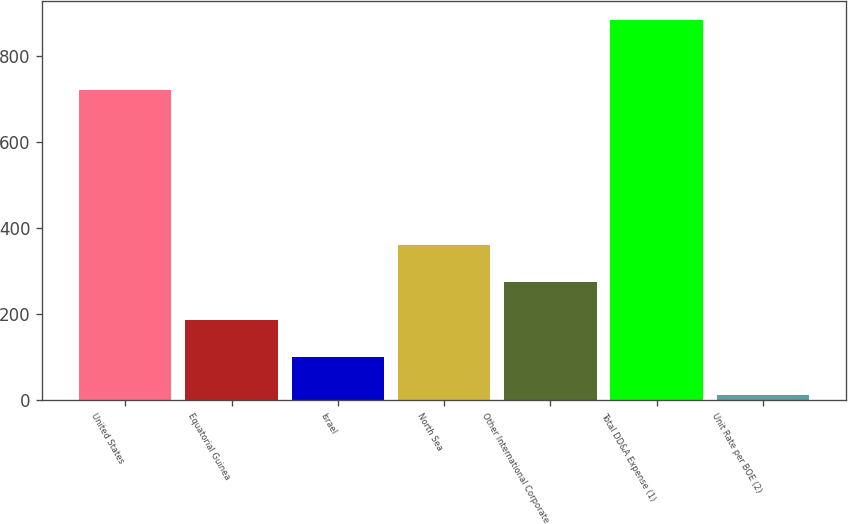Convert chart to OTSL. <chart><loc_0><loc_0><loc_500><loc_500><bar_chart><fcel>United States<fcel>Equatorial Guinea<fcel>Israel<fcel>North Sea<fcel>Other International Corporate<fcel>Total DD&A Expense (1)<fcel>Unit Rate per BOE (2)<nl><fcel>719<fcel>185.85<fcel>98.71<fcel>360.13<fcel>272.99<fcel>883<fcel>11.57<nl></chart> 